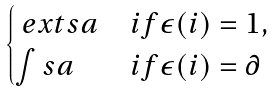<formula> <loc_0><loc_0><loc_500><loc_500>\begin{cases} \ e x t s { a } & i f \epsilon ( i ) = 1 , \\ \int s { a } & i f \epsilon ( i ) = \partial \\ \end{cases}</formula> 